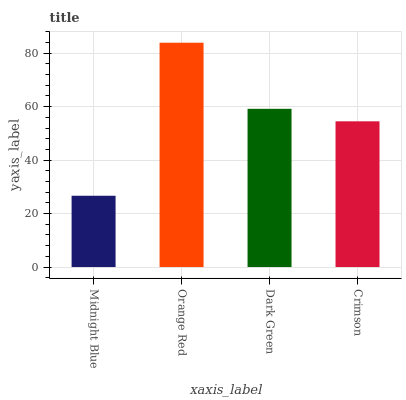Is Midnight Blue the minimum?
Answer yes or no. Yes. Is Orange Red the maximum?
Answer yes or no. Yes. Is Dark Green the minimum?
Answer yes or no. No. Is Dark Green the maximum?
Answer yes or no. No. Is Orange Red greater than Dark Green?
Answer yes or no. Yes. Is Dark Green less than Orange Red?
Answer yes or no. Yes. Is Dark Green greater than Orange Red?
Answer yes or no. No. Is Orange Red less than Dark Green?
Answer yes or no. No. Is Dark Green the high median?
Answer yes or no. Yes. Is Crimson the low median?
Answer yes or no. Yes. Is Orange Red the high median?
Answer yes or no. No. Is Orange Red the low median?
Answer yes or no. No. 